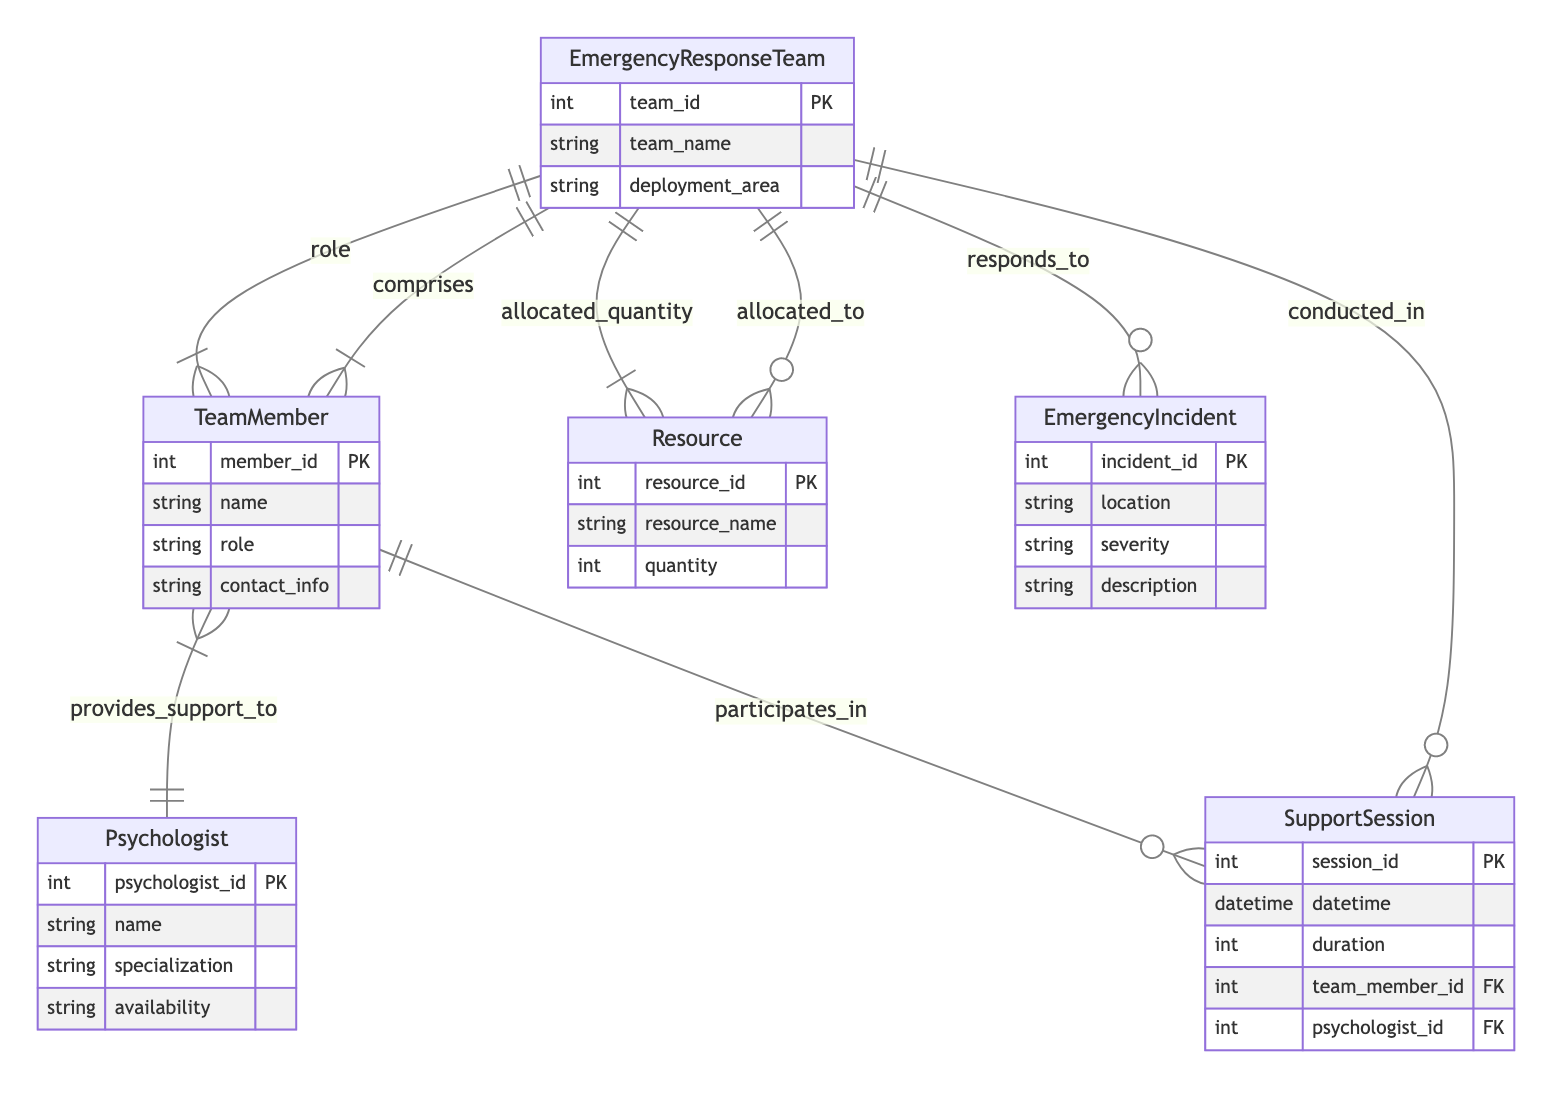What entities are included in the diagram? The diagram contains six entities: EmergencyResponseTeam, TeamMember, Psychologist, Resource, EmergencyIncident, and SupportSession.
Answer: EmergencyResponseTeam, TeamMember, Psychologist, Resource, EmergencyIncident, SupportSession How many relationships are there? There are five relationships in the diagram: responds_to, allocated_to, comprises, provides_support_to, and conducted_in.
Answer: 5 What is the role of the TeamMember in an EmergencyResponseTeam? The TeamMember has a role defined in the EmergencyResponseTeam through the comprises relationship. This relationship includes a 'role' attribute.
Answer: role Which entity responds to EmergencyIncident? The EmergencyResponseTeam responds to EmergencyIncident, as indicated by the responds_to relationship.
Answer: EmergencyResponseTeam How many resources can be allocated to each EmergencyResponseTeam? The diagram indicates a one-to-many relationship (one EmergencyResponseTeam can have many Resources allocated), but does not specify a numeric limit in the diagram. Thus, the quantity of resources can vary depending on allocation.
Answer: varies What is the purpose of the SupportSession? The SupportSession is conducted in an EmergencyResponseTeam, as indicated by the conducted_in relationship. It serves to provide psychological support during emergencies.
Answer: provide support How many Psychologists can support a TeamMember? The diagram shows a many-to-many relationship where a TeamMember can be supported by multiple Psychologists through the provides_support_to relationship.
Answer: many What does the allocated_to relationship specify? The allocated_to relationship specifies that resources are allocated to EmergencyResponseTeams, with the attribute 'allocated_quantity' indicating how many resources are assigned.
Answer: allocated_quantity In what context are SupportSessions conducted? SupportSessions are conducted in the context of EmergencyResponseTeams as per the conducted_in relationship.
Answer: EmergencyResponseTeam 